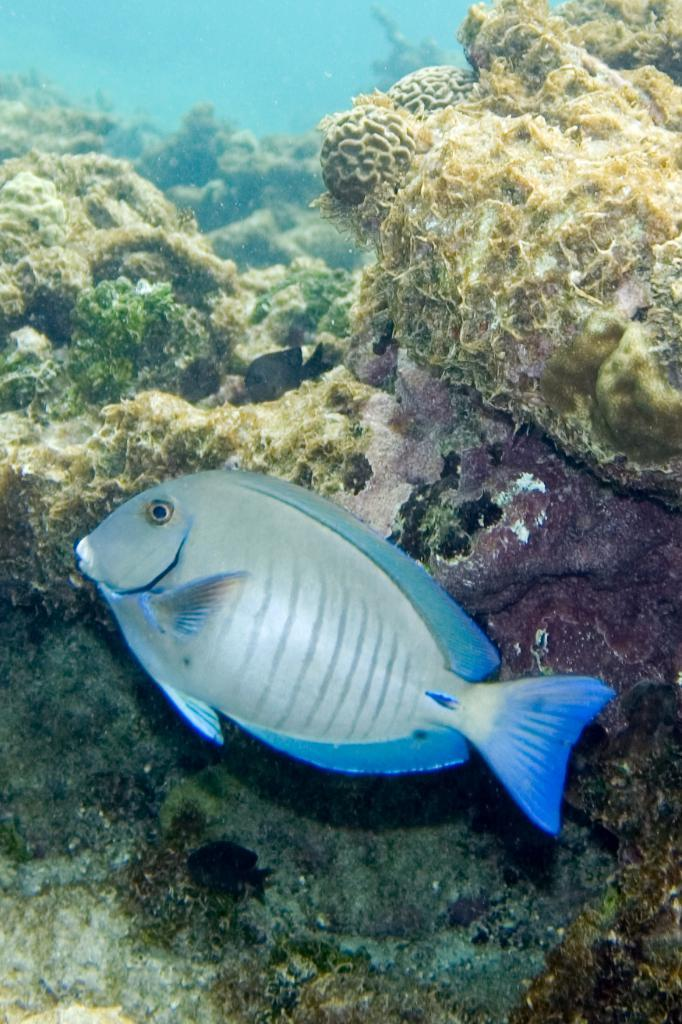What is the primary element visible in the image? There is water visible in the image. What type of animal can be seen in the water? There is a fish in the image. What else can be seen in the water besides the fish? There are underwater plants in the image. What type of rain can be seen falling in the image? There is no rain visible in the image; it is set underwater. 